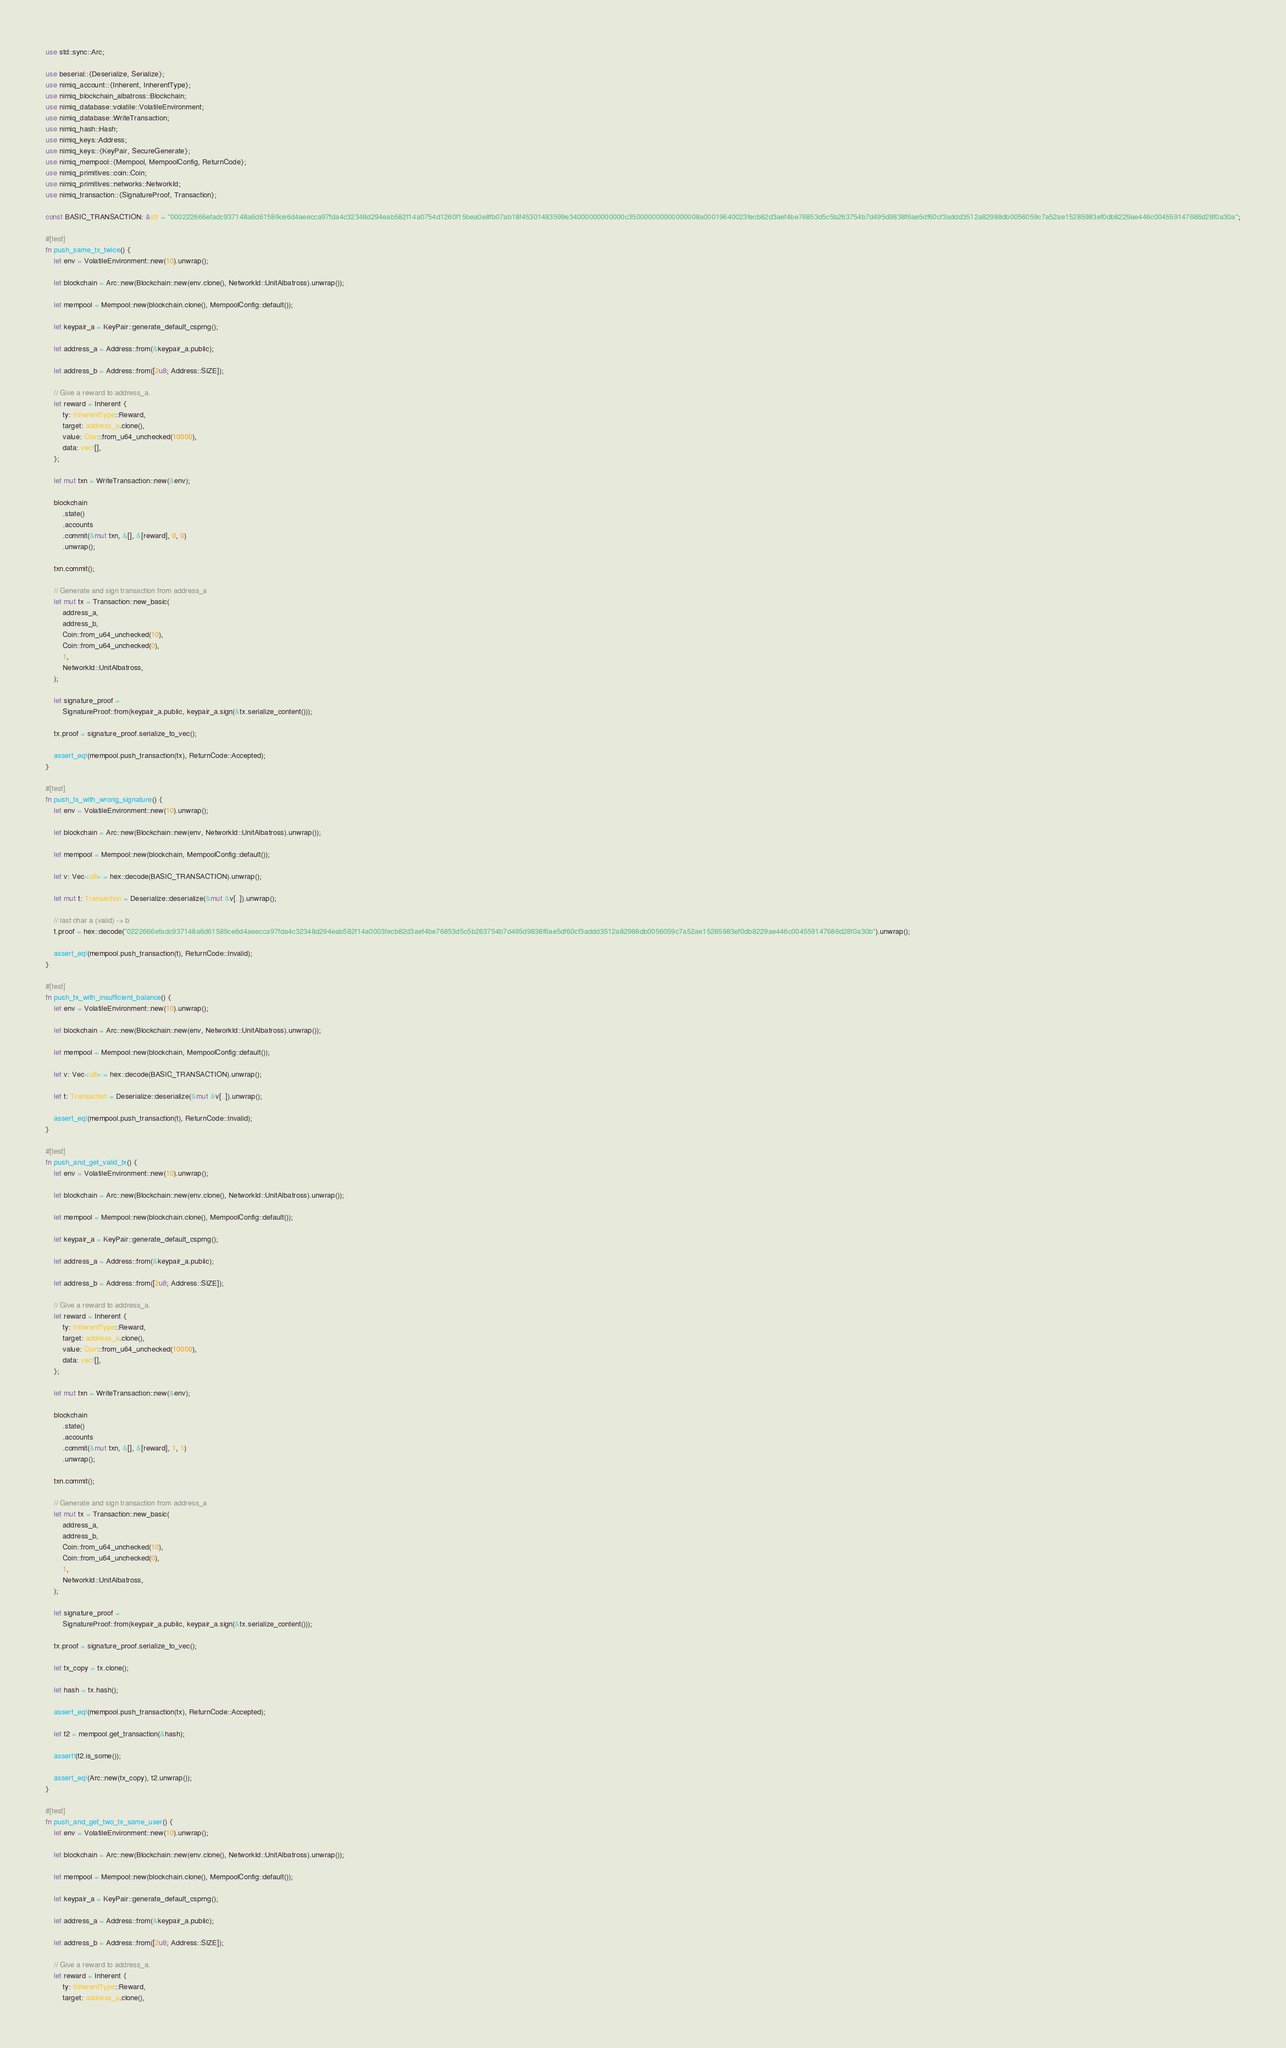Convert code to text. <code><loc_0><loc_0><loc_500><loc_500><_Rust_>use std::sync::Arc;

use beserial::{Deserialize, Serialize};
use nimiq_account::{Inherent, InherentType};
use nimiq_blockchain_albatross::Blockchain;
use nimiq_database::volatile::VolatileEnvironment;
use nimiq_database::WriteTransaction;
use nimiq_hash::Hash;
use nimiq_keys::Address;
use nimiq_keys::{KeyPair, SecureGenerate};
use nimiq_mempool::{Mempool, MempoolConfig, ReturnCode};
use nimiq_primitives::coin::Coin;
use nimiq_primitives::networks::NetworkId;
use nimiq_transaction::{SignatureProof, Transaction};

const BASIC_TRANSACTION: &str = "000222666efadc937148a6d61589ce6d4aeecca97fda4c32348d294eab582f14a0754d1260f15bea0e8fb07ab18f45301483599e34000000000000c350000000000000008a00019640023fecb82d3aef4be76853d5c5b263754b7d495d9838f6ae5df60cf3addd3512a82988db0056059c7a52ae15285983ef0db8229ae446c004559147686d28f0a30a";

#[test]
fn push_same_tx_twice() {
    let env = VolatileEnvironment::new(10).unwrap();

    let blockchain = Arc::new(Blockchain::new(env.clone(), NetworkId::UnitAlbatross).unwrap());

    let mempool = Mempool::new(blockchain.clone(), MempoolConfig::default());

    let keypair_a = KeyPair::generate_default_csprng();

    let address_a = Address::from(&keypair_a.public);

    let address_b = Address::from([2u8; Address::SIZE]);

    // Give a reward to address_a.
    let reward = Inherent {
        ty: InherentType::Reward,
        target: address_a.clone(),
        value: Coin::from_u64_unchecked(10000),
        data: vec![],
    };

    let mut txn = WriteTransaction::new(&env);

    blockchain
        .state()
        .accounts
        .commit(&mut txn, &[], &[reward], 0, 0)
        .unwrap();

    txn.commit();

    // Generate and sign transaction from address_a
    let mut tx = Transaction::new_basic(
        address_a,
        address_b,
        Coin::from_u64_unchecked(10),
        Coin::from_u64_unchecked(0),
        1,
        NetworkId::UnitAlbatross,
    );

    let signature_proof =
        SignatureProof::from(keypair_a.public, keypair_a.sign(&tx.serialize_content()));

    tx.proof = signature_proof.serialize_to_vec();

    assert_eq!(mempool.push_transaction(tx), ReturnCode::Accepted);
}

#[test]
fn push_tx_with_wrong_signature() {
    let env = VolatileEnvironment::new(10).unwrap();

    let blockchain = Arc::new(Blockchain::new(env, NetworkId::UnitAlbatross).unwrap());

    let mempool = Mempool::new(blockchain, MempoolConfig::default());

    let v: Vec<u8> = hex::decode(BASIC_TRANSACTION).unwrap();

    let mut t: Transaction = Deserialize::deserialize(&mut &v[..]).unwrap();

    // last char a (valid) -> b
    t.proof = hex::decode("0222666efadc937148a6d61589ce6d4aeecca97fda4c32348d294eab582f14a0003fecb82d3aef4be76853d5c5b263754b7d495d9838f6ae5df60cf3addd3512a82988db0056059c7a52ae15285983ef0db8229ae446c004559147686d28f0a30b").unwrap();

    assert_eq!(mempool.push_transaction(t), ReturnCode::Invalid);
}

#[test]
fn push_tx_with_insufficient_balance() {
    let env = VolatileEnvironment::new(10).unwrap();

    let blockchain = Arc::new(Blockchain::new(env, NetworkId::UnitAlbatross).unwrap());

    let mempool = Mempool::new(blockchain, MempoolConfig::default());

    let v: Vec<u8> = hex::decode(BASIC_TRANSACTION).unwrap();

    let t: Transaction = Deserialize::deserialize(&mut &v[..]).unwrap();

    assert_eq!(mempool.push_transaction(t), ReturnCode::Invalid);
}

#[test]
fn push_and_get_valid_tx() {
    let env = VolatileEnvironment::new(10).unwrap();

    let blockchain = Arc::new(Blockchain::new(env.clone(), NetworkId::UnitAlbatross).unwrap());

    let mempool = Mempool::new(blockchain.clone(), MempoolConfig::default());

    let keypair_a = KeyPair::generate_default_csprng();

    let address_a = Address::from(&keypair_a.public);

    let address_b = Address::from([2u8; Address::SIZE]);

    // Give a reward to address_a.
    let reward = Inherent {
        ty: InherentType::Reward,
        target: address_a.clone(),
        value: Coin::from_u64_unchecked(10000),
        data: vec![],
    };

    let mut txn = WriteTransaction::new(&env);

    blockchain
        .state()
        .accounts
        .commit(&mut txn, &[], &[reward], 1, 1)
        .unwrap();

    txn.commit();

    // Generate and sign transaction from address_a
    let mut tx = Transaction::new_basic(
        address_a,
        address_b,
        Coin::from_u64_unchecked(10),
        Coin::from_u64_unchecked(0),
        1,
        NetworkId::UnitAlbatross,
    );

    let signature_proof =
        SignatureProof::from(keypair_a.public, keypair_a.sign(&tx.serialize_content()));

    tx.proof = signature_proof.serialize_to_vec();

    let tx_copy = tx.clone();

    let hash = tx.hash();

    assert_eq!(mempool.push_transaction(tx), ReturnCode::Accepted);

    let t2 = mempool.get_transaction(&hash);

    assert!(t2.is_some());

    assert_eq!(Arc::new(tx_copy), t2.unwrap());
}

#[test]
fn push_and_get_two_tx_same_user() {
    let env = VolatileEnvironment::new(10).unwrap();

    let blockchain = Arc::new(Blockchain::new(env.clone(), NetworkId::UnitAlbatross).unwrap());

    let mempool = Mempool::new(blockchain.clone(), MempoolConfig::default());

    let keypair_a = KeyPair::generate_default_csprng();

    let address_a = Address::from(&keypair_a.public);

    let address_b = Address::from([2u8; Address::SIZE]);

    // Give a reward to address_a.
    let reward = Inherent {
        ty: InherentType::Reward,
        target: address_a.clone(),</code> 